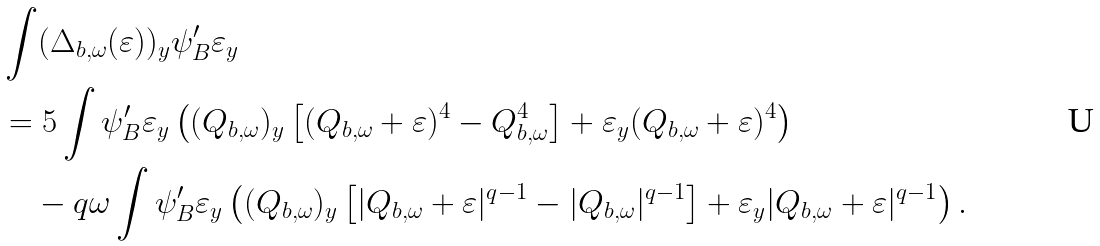<formula> <loc_0><loc_0><loc_500><loc_500>& \int ( \Delta _ { b , \omega } ( \varepsilon ) ) _ { y } \psi _ { B } ^ { \prime } \varepsilon _ { y } \\ & = 5 \int \psi _ { B } ^ { \prime } \varepsilon _ { y } \left ( ( Q _ { b , \omega } ) _ { y } \left [ ( Q _ { b , \omega } + \varepsilon ) ^ { 4 } - Q _ { b , \omega } ^ { 4 } \right ] + \varepsilon _ { y } ( Q _ { b , \omega } + \varepsilon ) ^ { 4 } \right ) \\ & \quad - q \omega \int \psi _ { B } ^ { \prime } \varepsilon _ { y } \left ( ( Q _ { b , \omega } ) _ { y } \left [ | Q _ { b , \omega } + \varepsilon | ^ { q - 1 } - | Q _ { b , \omega } | ^ { q - 1 } \right ] + \varepsilon _ { y } | Q _ { b , \omega } + \varepsilon | ^ { q - 1 } \right ) .</formula> 